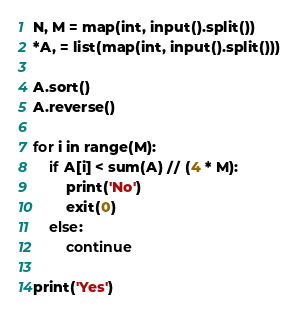<code> <loc_0><loc_0><loc_500><loc_500><_Python_>N, M = map(int, input().split())
*A, = list(map(int, input().split()))

A.sort()
A.reverse()

for i in range(M):
    if A[i] < sum(A) // (4 * M):
        print('No')
        exit(0)
    else:
        continue

print('Yes')</code> 